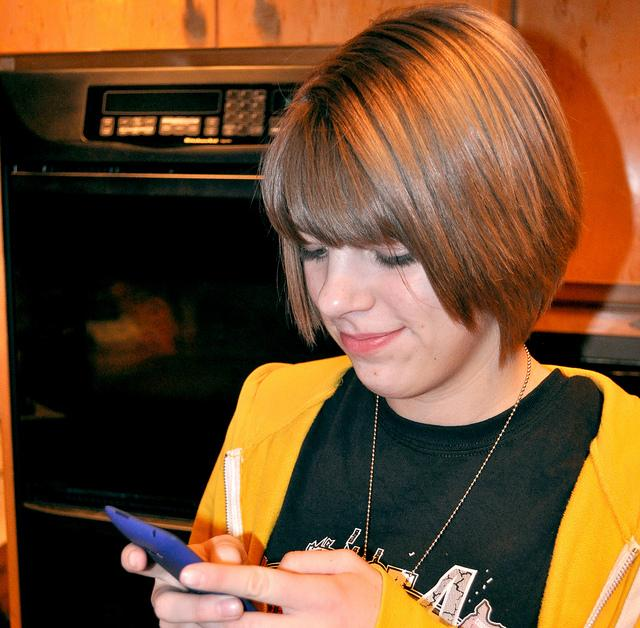What is she doing?

Choices:
A) playing music
B) learning phone
C) using phone
D) cleaning phone using phone 